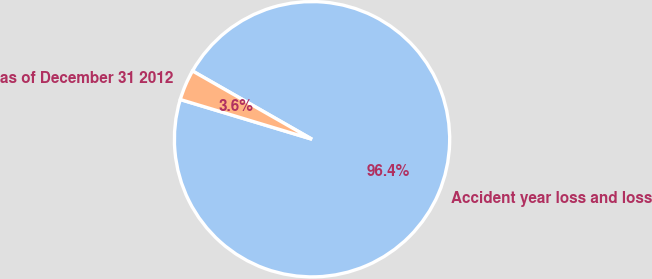Convert chart to OTSL. <chart><loc_0><loc_0><loc_500><loc_500><pie_chart><fcel>Accident year loss and loss<fcel>as of December 31 2012<nl><fcel>96.4%<fcel>3.6%<nl></chart> 